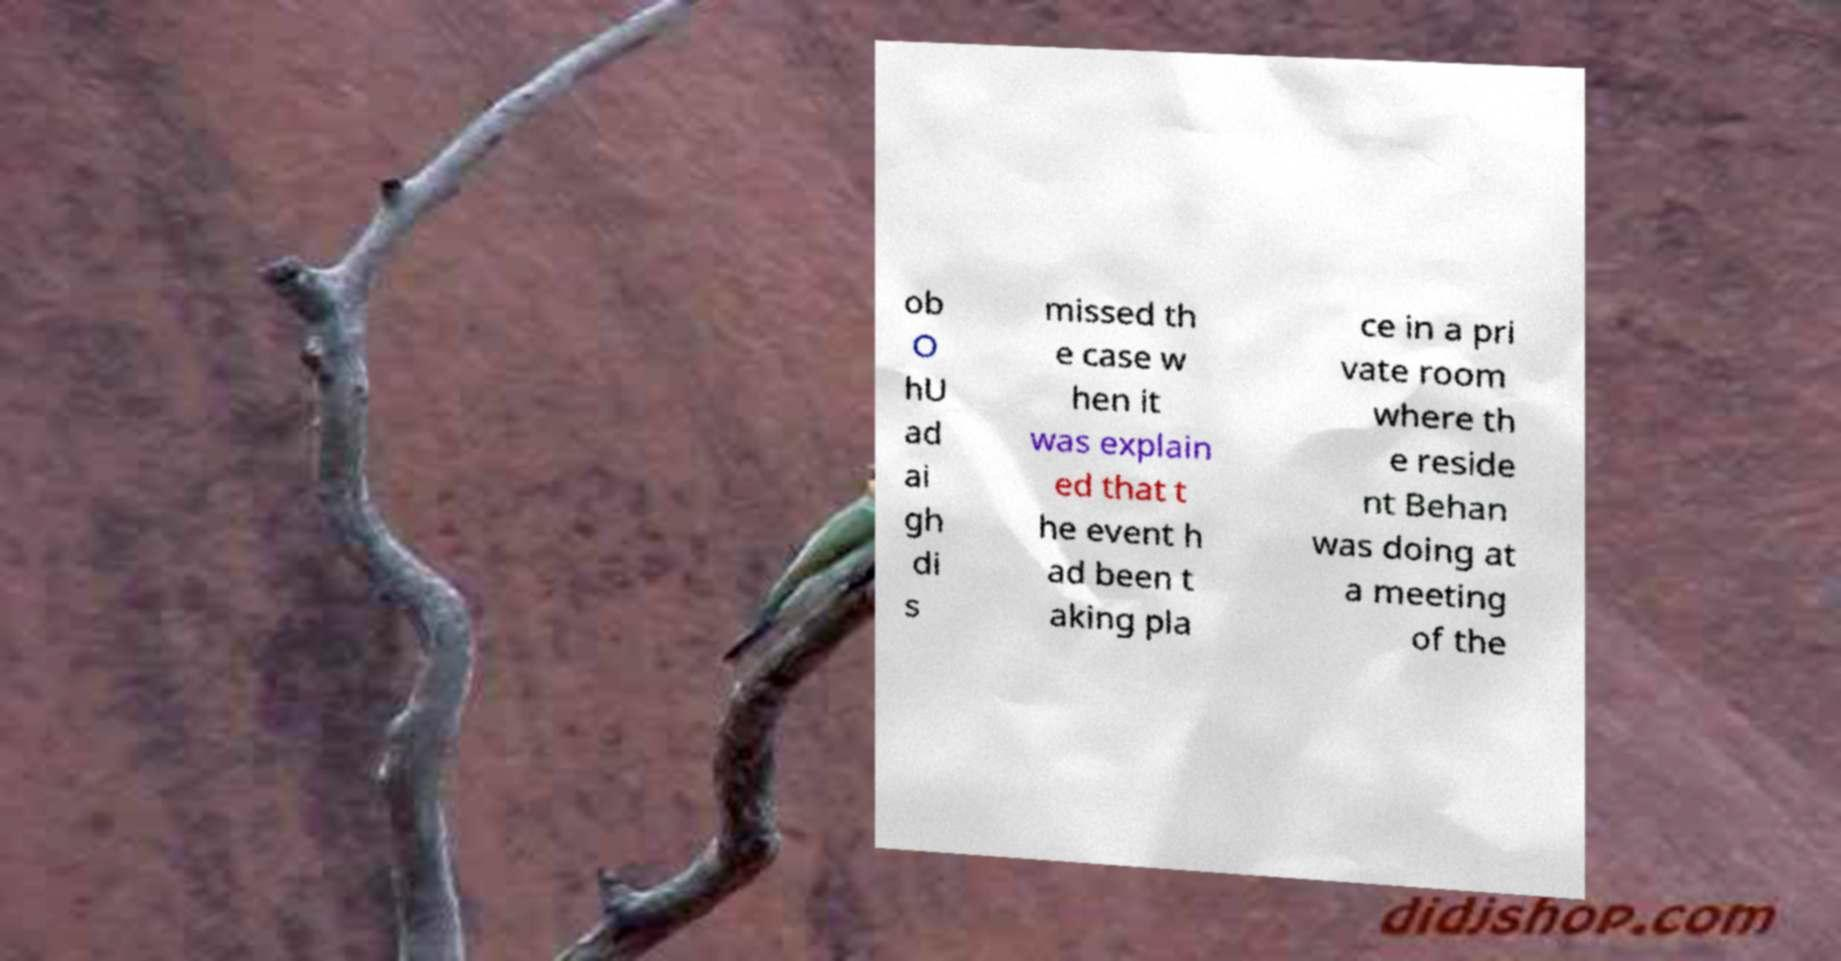There's text embedded in this image that I need extracted. Can you transcribe it verbatim? ob O hU ad ai gh di s missed th e case w hen it was explain ed that t he event h ad been t aking pla ce in a pri vate room where th e reside nt Behan was doing at a meeting of the 